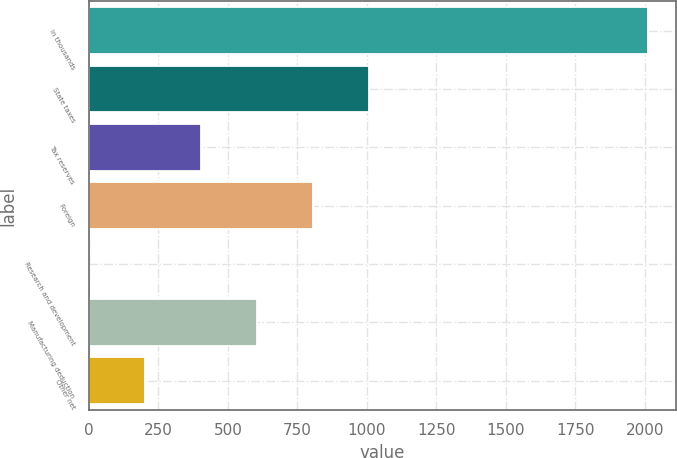Convert chart to OTSL. <chart><loc_0><loc_0><loc_500><loc_500><bar_chart><fcel>In thousands<fcel>State taxes<fcel>Tax reserves<fcel>Foreign<fcel>Research and development<fcel>Manufacturing deduction<fcel>Other net<nl><fcel>2012<fcel>1006.1<fcel>402.56<fcel>804.92<fcel>0.2<fcel>603.74<fcel>201.38<nl></chart> 